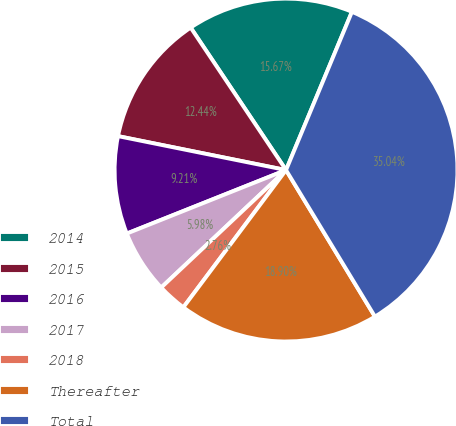Convert chart. <chart><loc_0><loc_0><loc_500><loc_500><pie_chart><fcel>2014<fcel>2015<fcel>2016<fcel>2017<fcel>2018<fcel>Thereafter<fcel>Total<nl><fcel>15.67%<fcel>12.44%<fcel>9.21%<fcel>5.98%<fcel>2.76%<fcel>18.9%<fcel>35.04%<nl></chart> 